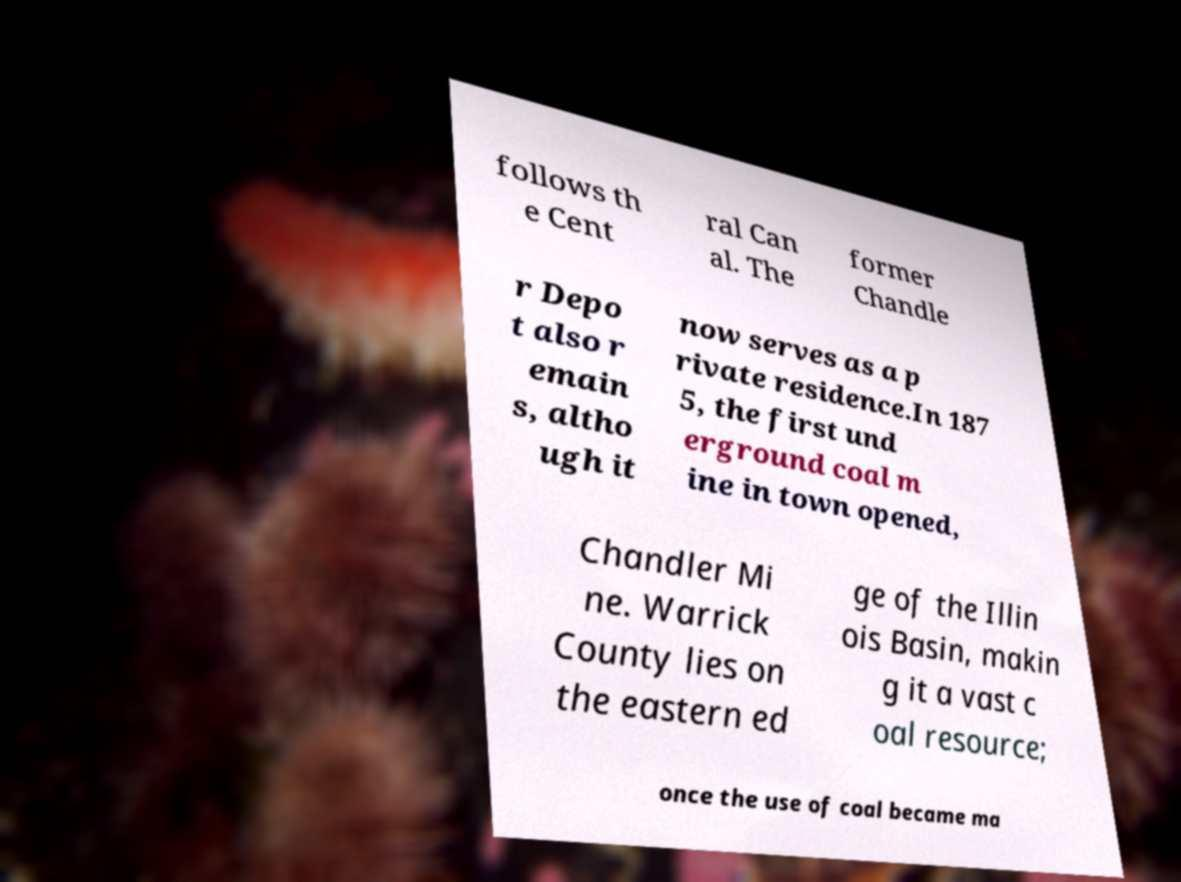Please read and relay the text visible in this image. What does it say? follows th e Cent ral Can al. The former Chandle r Depo t also r emain s, altho ugh it now serves as a p rivate residence.In 187 5, the first und erground coal m ine in town opened, Chandler Mi ne. Warrick County lies on the eastern ed ge of the Illin ois Basin, makin g it a vast c oal resource; once the use of coal became ma 